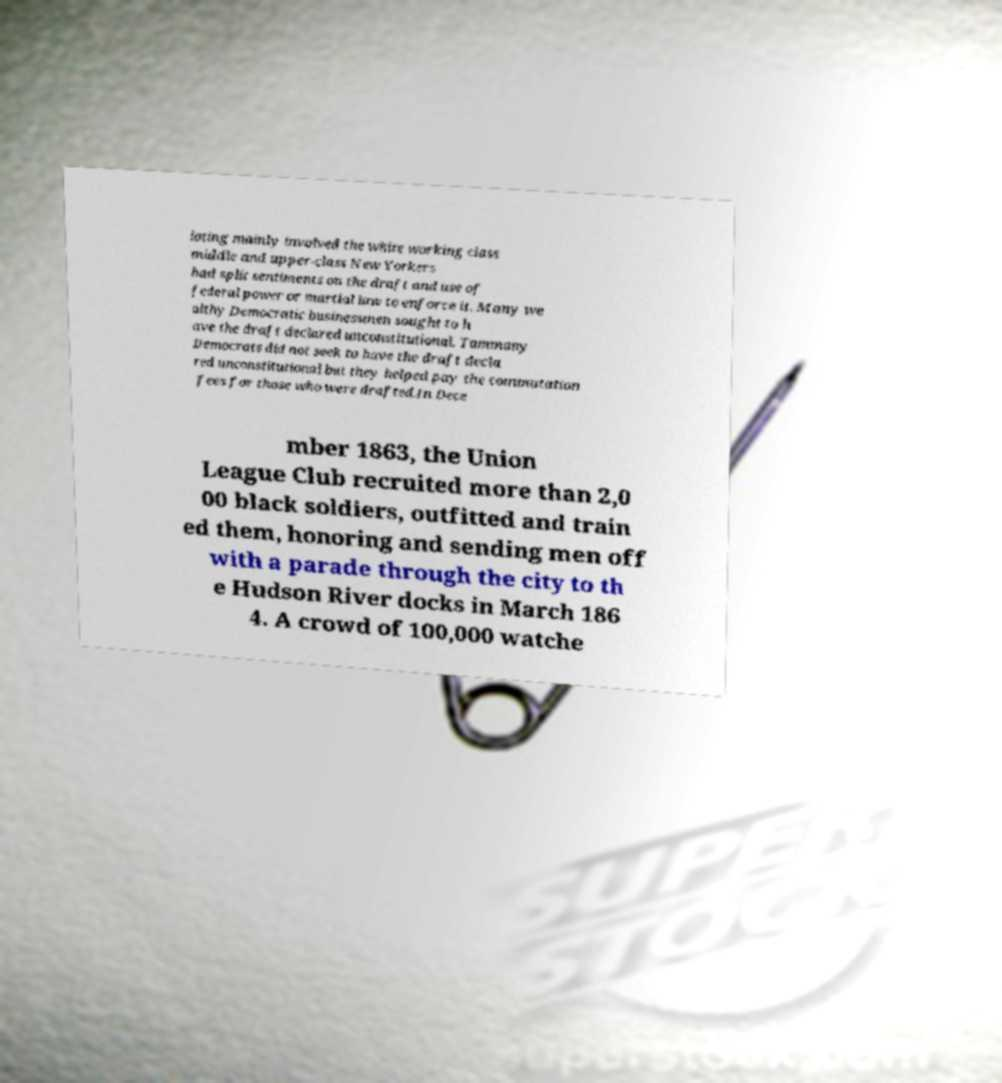I need the written content from this picture converted into text. Can you do that? ioting mainly involved the white working class middle and upper-class New Yorkers had split sentiments on the draft and use of federal power or martial law to enforce it. Many we althy Democratic businessmen sought to h ave the draft declared unconstitutional. Tammany Democrats did not seek to have the draft decla red unconstitutional but they helped pay the commutation fees for those who were drafted.In Dece mber 1863, the Union League Club recruited more than 2,0 00 black soldiers, outfitted and train ed them, honoring and sending men off with a parade through the city to th e Hudson River docks in March 186 4. A crowd of 100,000 watche 